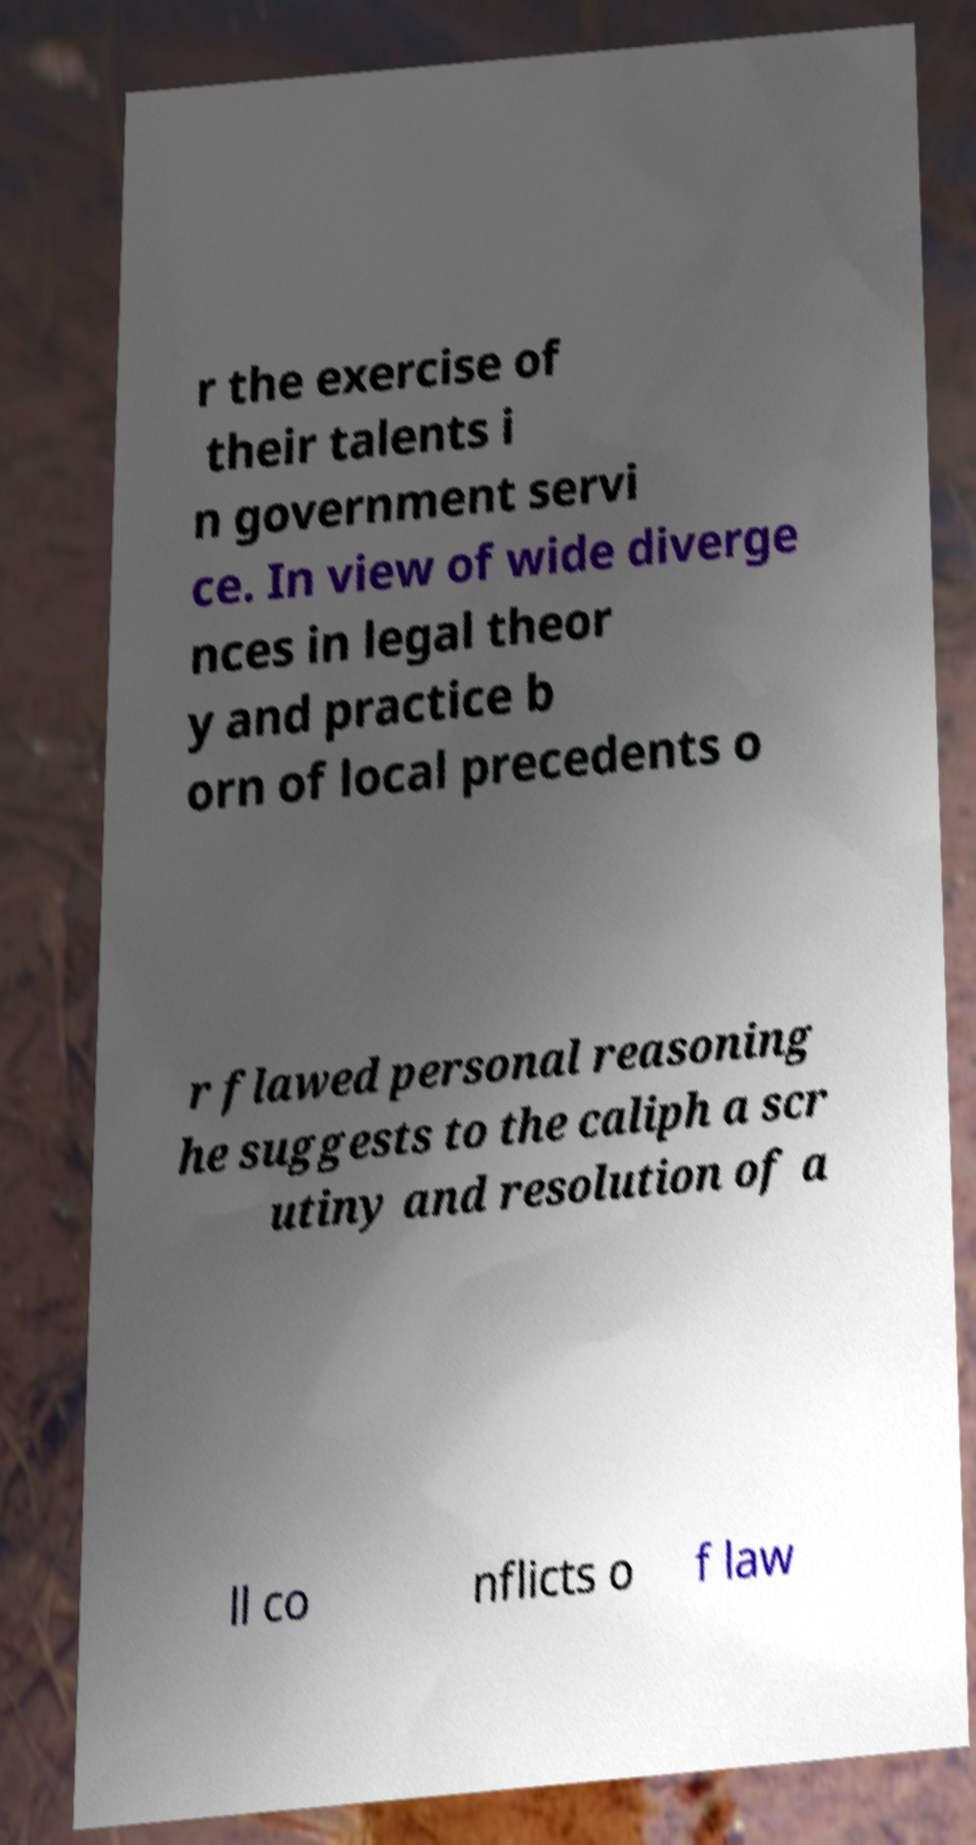Could you extract and type out the text from this image? r the exercise of their talents i n government servi ce. In view of wide diverge nces in legal theor y and practice b orn of local precedents o r flawed personal reasoning he suggests to the caliph a scr utiny and resolution of a ll co nflicts o f law 